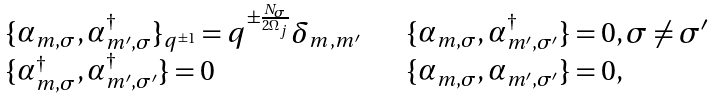<formula> <loc_0><loc_0><loc_500><loc_500>\begin{array} { l l } \{ \alpha _ { m , \sigma } , \alpha _ { m ^ { \prime } , \sigma } ^ { \dagger } \} _ { q ^ { \pm 1 } } = q ^ { \pm \frac { N _ { \sigma } } { 2 \Omega _ { j } } } \delta _ { m , m ^ { \prime } } \quad & \{ \alpha _ { m , \sigma } , \alpha _ { m ^ { \prime } , \sigma ^ { \prime } } ^ { \dagger } \} = 0 , \sigma \neq \sigma ^ { \prime } \\ \{ \alpha _ { m , \sigma } ^ { \dagger } , \alpha _ { m ^ { \prime } , \sigma ^ { \prime } } ^ { \dagger } \} = 0 & \{ \alpha _ { m , \sigma } , \alpha _ { m ^ { \prime } , \sigma ^ { \prime } } \} = 0 , \end{array}</formula> 